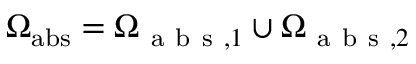Convert formula to latex. <formula><loc_0><loc_0><loc_500><loc_500>\Omega _ { a b s } = \Omega _ { a b s , 1 } \cup \Omega _ { a b s , 2 }</formula> 